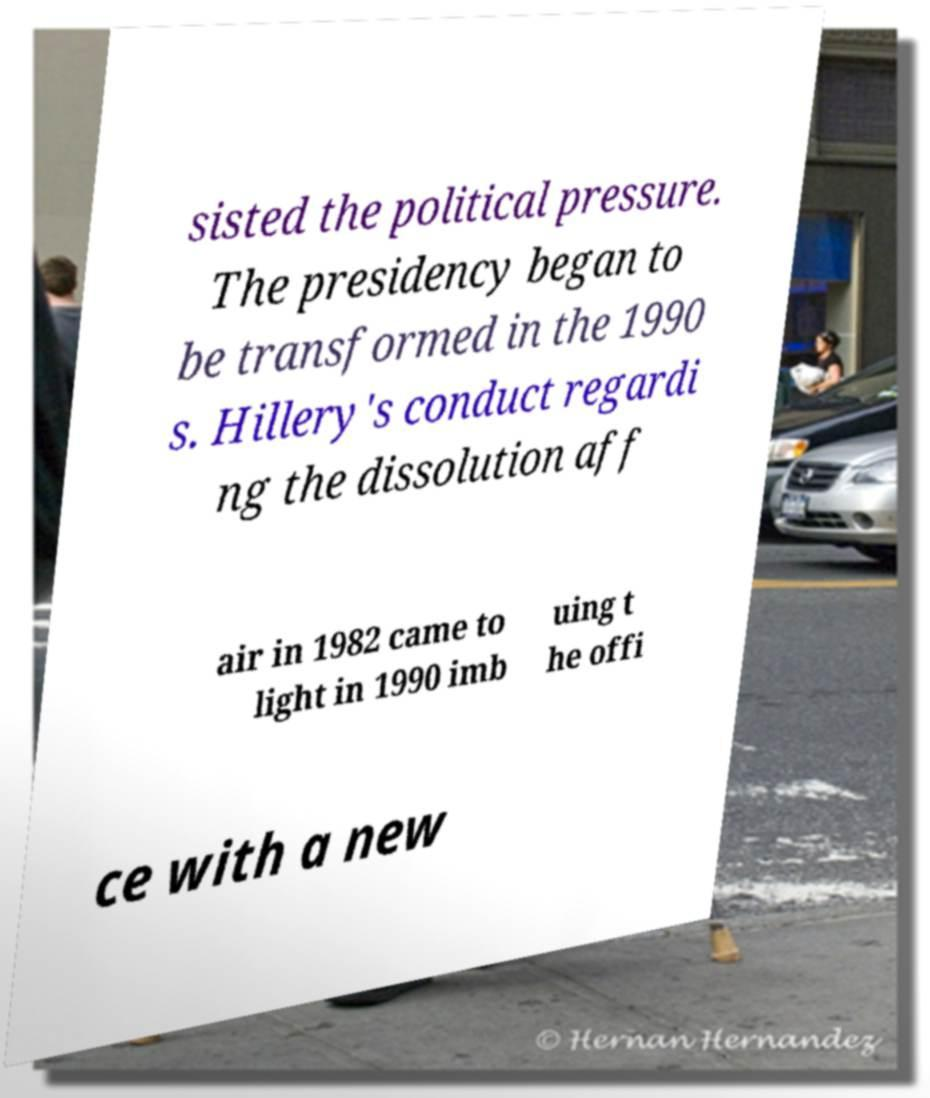I need the written content from this picture converted into text. Can you do that? sisted the political pressure. The presidency began to be transformed in the 1990 s. Hillery's conduct regardi ng the dissolution aff air in 1982 came to light in 1990 imb uing t he offi ce with a new 